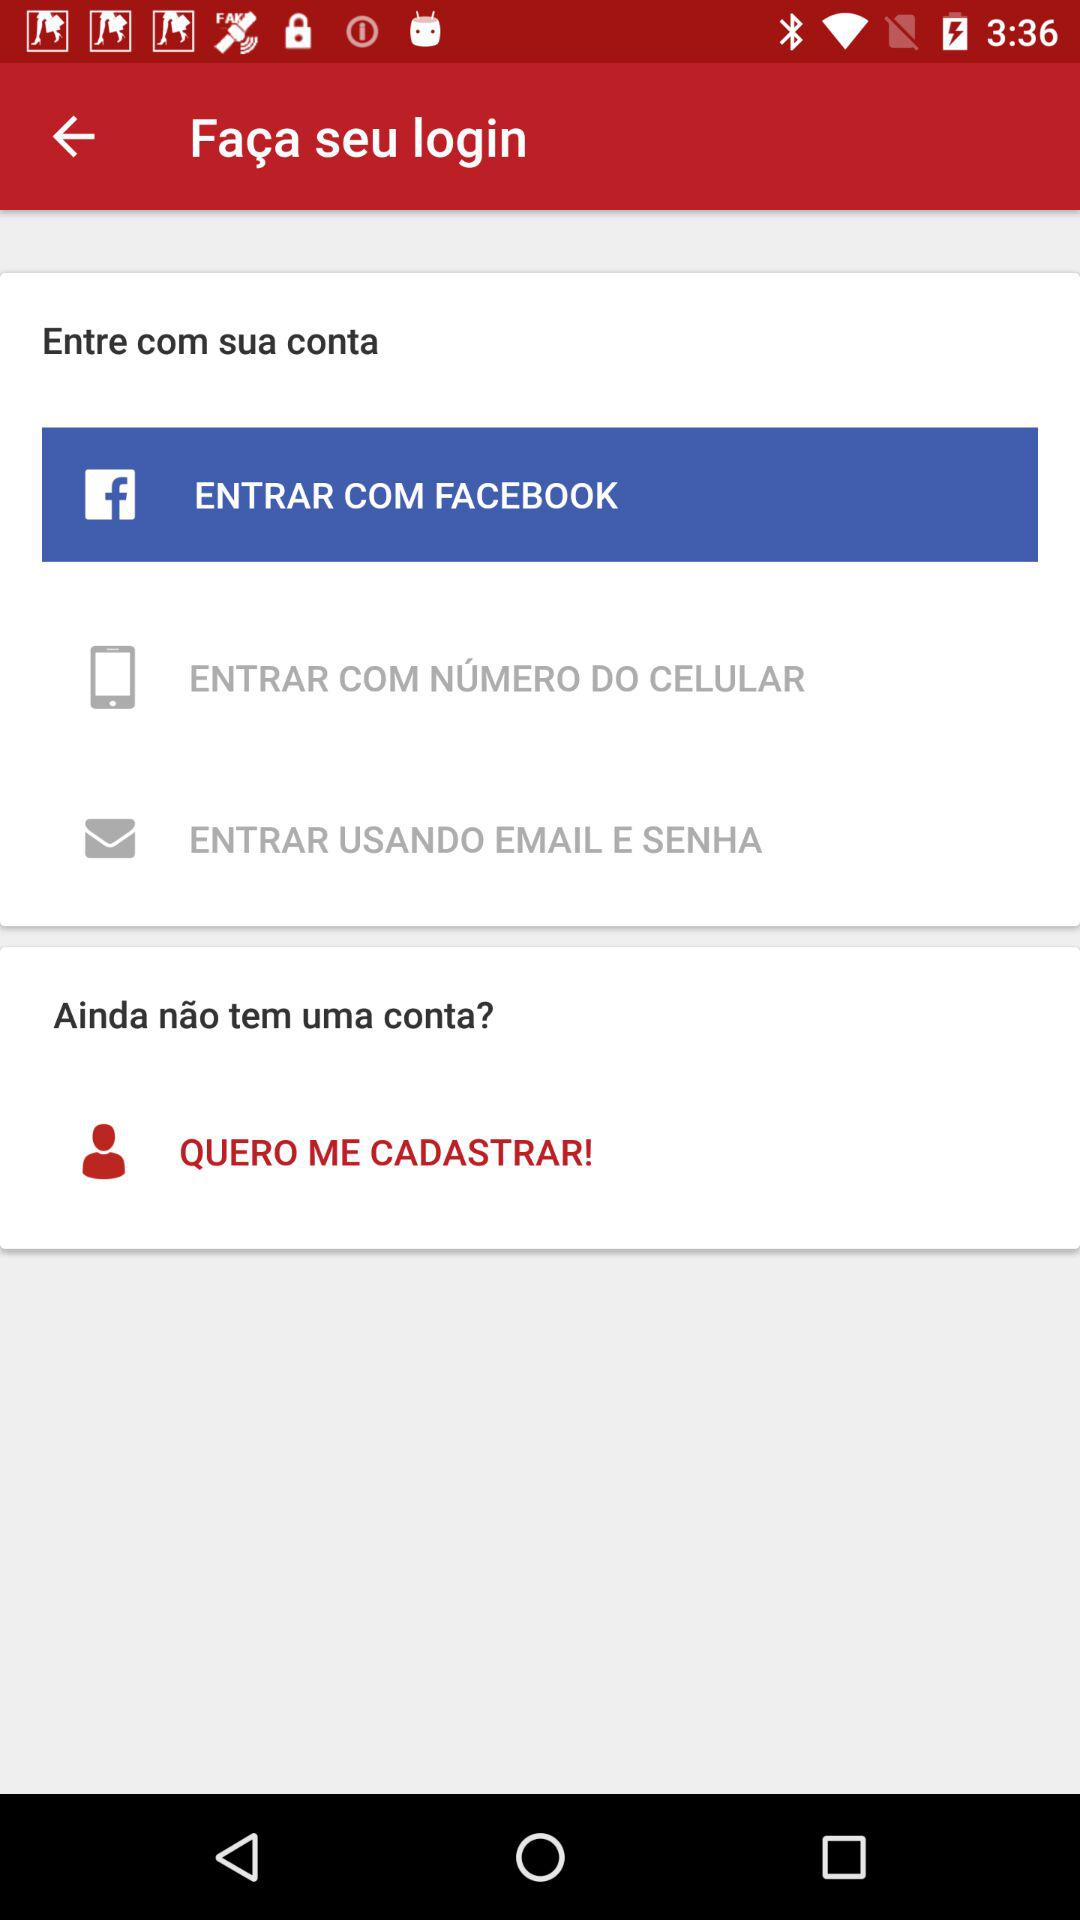How many options are there to login?
Answer the question using a single word or phrase. 3 